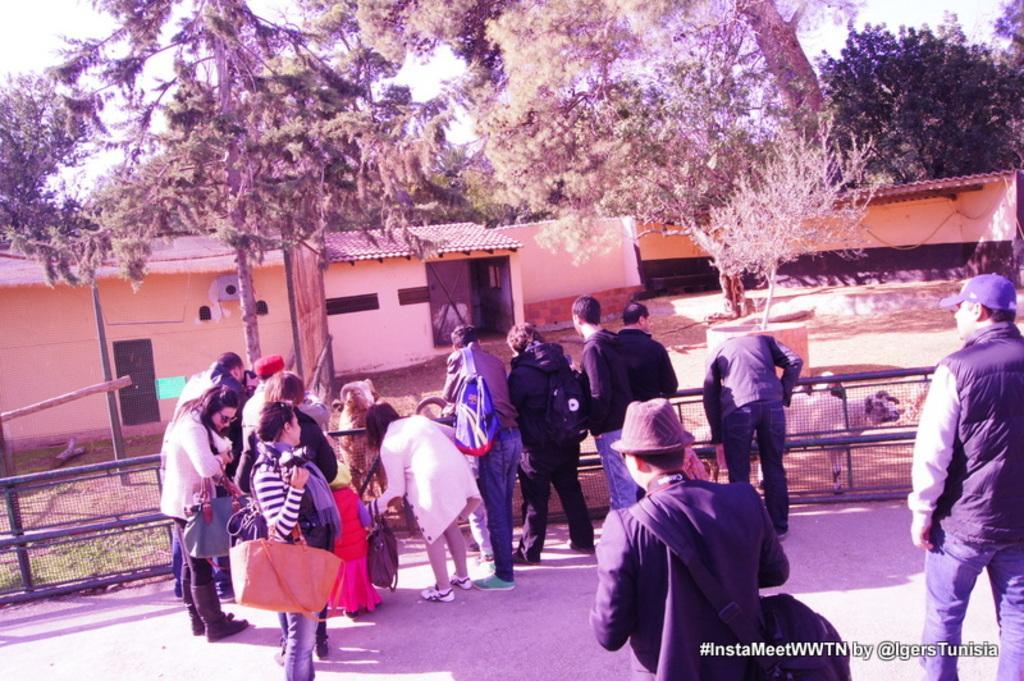Please provide a concise description of this image. This image consists of many people standing on the road. At the bottom, there is a road. In the background, there is a small house. It looks like the image is clicked in a zoo park. There are animals beyond the fencing. 